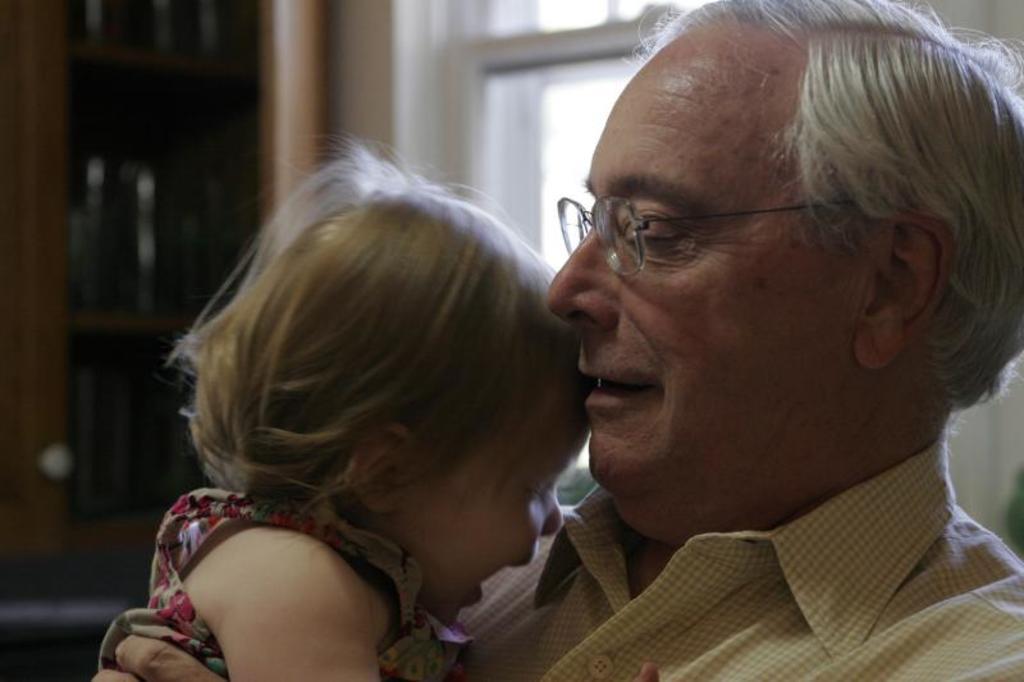Can you describe this image briefly? In this picture we are seeing that one old man carrying a baby. 